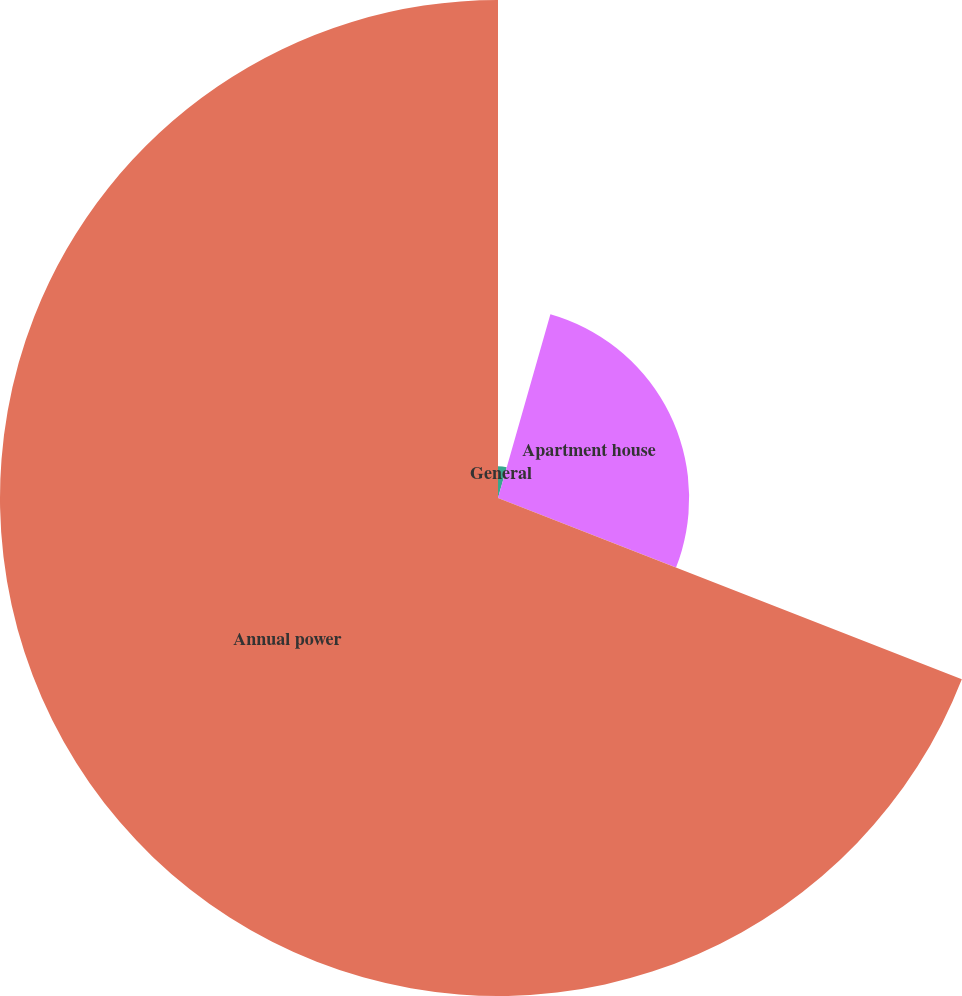Convert chart. <chart><loc_0><loc_0><loc_500><loc_500><pie_chart><fcel>General<fcel>Apartment house<fcel>Annual power<nl><fcel>4.42%<fcel>26.51%<fcel>69.07%<nl></chart> 